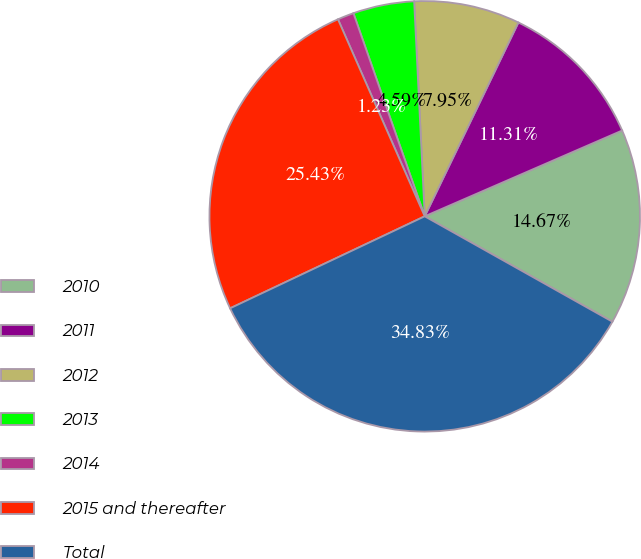<chart> <loc_0><loc_0><loc_500><loc_500><pie_chart><fcel>2010<fcel>2011<fcel>2012<fcel>2013<fcel>2014<fcel>2015 and thereafter<fcel>Total<nl><fcel>14.67%<fcel>11.31%<fcel>7.95%<fcel>4.59%<fcel>1.23%<fcel>25.43%<fcel>34.83%<nl></chart> 